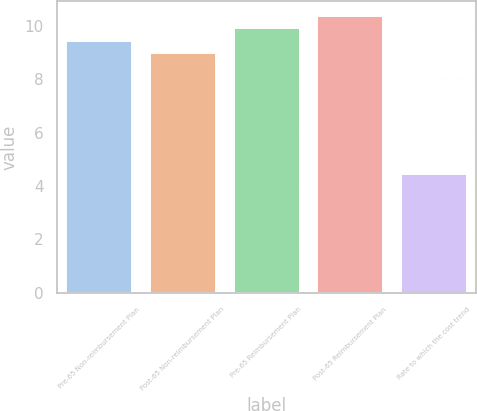Convert chart to OTSL. <chart><loc_0><loc_0><loc_500><loc_500><bar_chart><fcel>Pre-65 Non-reimbursement Plan<fcel>Post-65 Non-reimbursement Plan<fcel>Pre-65 Reimbursement Plan<fcel>Post-65 Reimbursement Plan<fcel>Rate to which the cost trend<nl><fcel>9.47<fcel>9<fcel>9.94<fcel>10.41<fcel>4.5<nl></chart> 